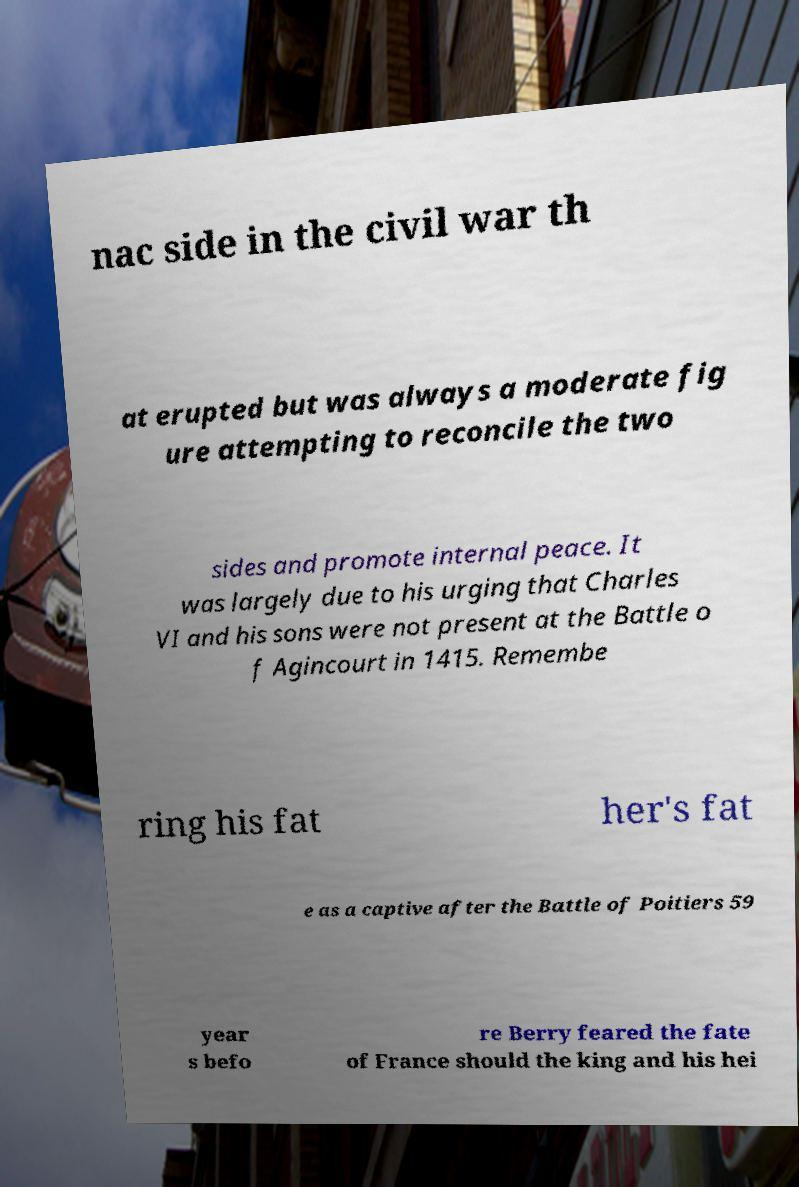Could you assist in decoding the text presented in this image and type it out clearly? nac side in the civil war th at erupted but was always a moderate fig ure attempting to reconcile the two sides and promote internal peace. It was largely due to his urging that Charles VI and his sons were not present at the Battle o f Agincourt in 1415. Remembe ring his fat her's fat e as a captive after the Battle of Poitiers 59 year s befo re Berry feared the fate of France should the king and his hei 